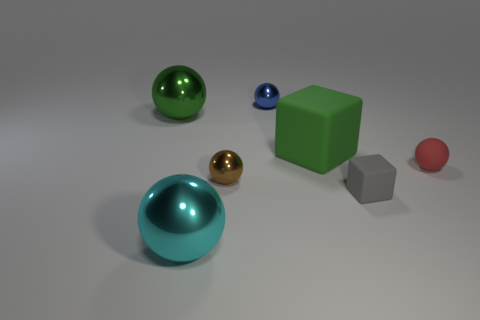What color is the large sphere in front of the tiny red ball?
Give a very brief answer. Cyan. How many things are either big shiny spheres that are behind the tiny rubber cube or big balls that are behind the small gray block?
Your response must be concise. 1. How many big green metallic things are the same shape as the large green rubber thing?
Give a very brief answer. 0. There is a matte block that is the same size as the green metal sphere; what color is it?
Offer a very short reply. Green. What is the color of the small metal ball behind the large metallic object on the left side of the big metal sphere that is in front of the tiny brown sphere?
Your response must be concise. Blue. Is the size of the blue thing the same as the green thing that is on the left side of the big green rubber object?
Provide a succinct answer. No. What number of objects are tiny green metal blocks or small brown things?
Give a very brief answer. 1. Are there any tiny purple cubes made of the same material as the tiny brown ball?
Make the answer very short. No. There is a thing that is the same color as the big matte cube; what is its size?
Your answer should be compact. Large. There is a big shiny ball that is in front of the small cube that is in front of the blue sphere; what color is it?
Provide a succinct answer. Cyan. 